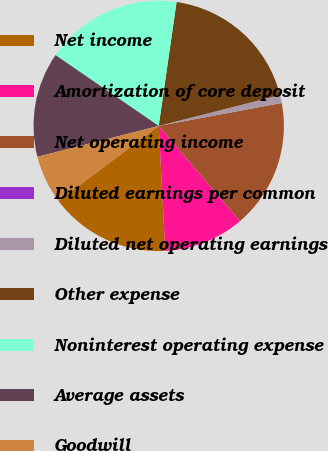<chart> <loc_0><loc_0><loc_500><loc_500><pie_chart><fcel>Net income<fcel>Amortization of core deposit<fcel>Net operating income<fcel>Diluted earnings per common<fcel>Diluted net operating earnings<fcel>Other expense<fcel>Noninterest operating expense<fcel>Average assets<fcel>Goodwill<nl><fcel>15.62%<fcel>10.42%<fcel>16.67%<fcel>0.0%<fcel>1.04%<fcel>18.75%<fcel>17.71%<fcel>13.54%<fcel>6.25%<nl></chart> 